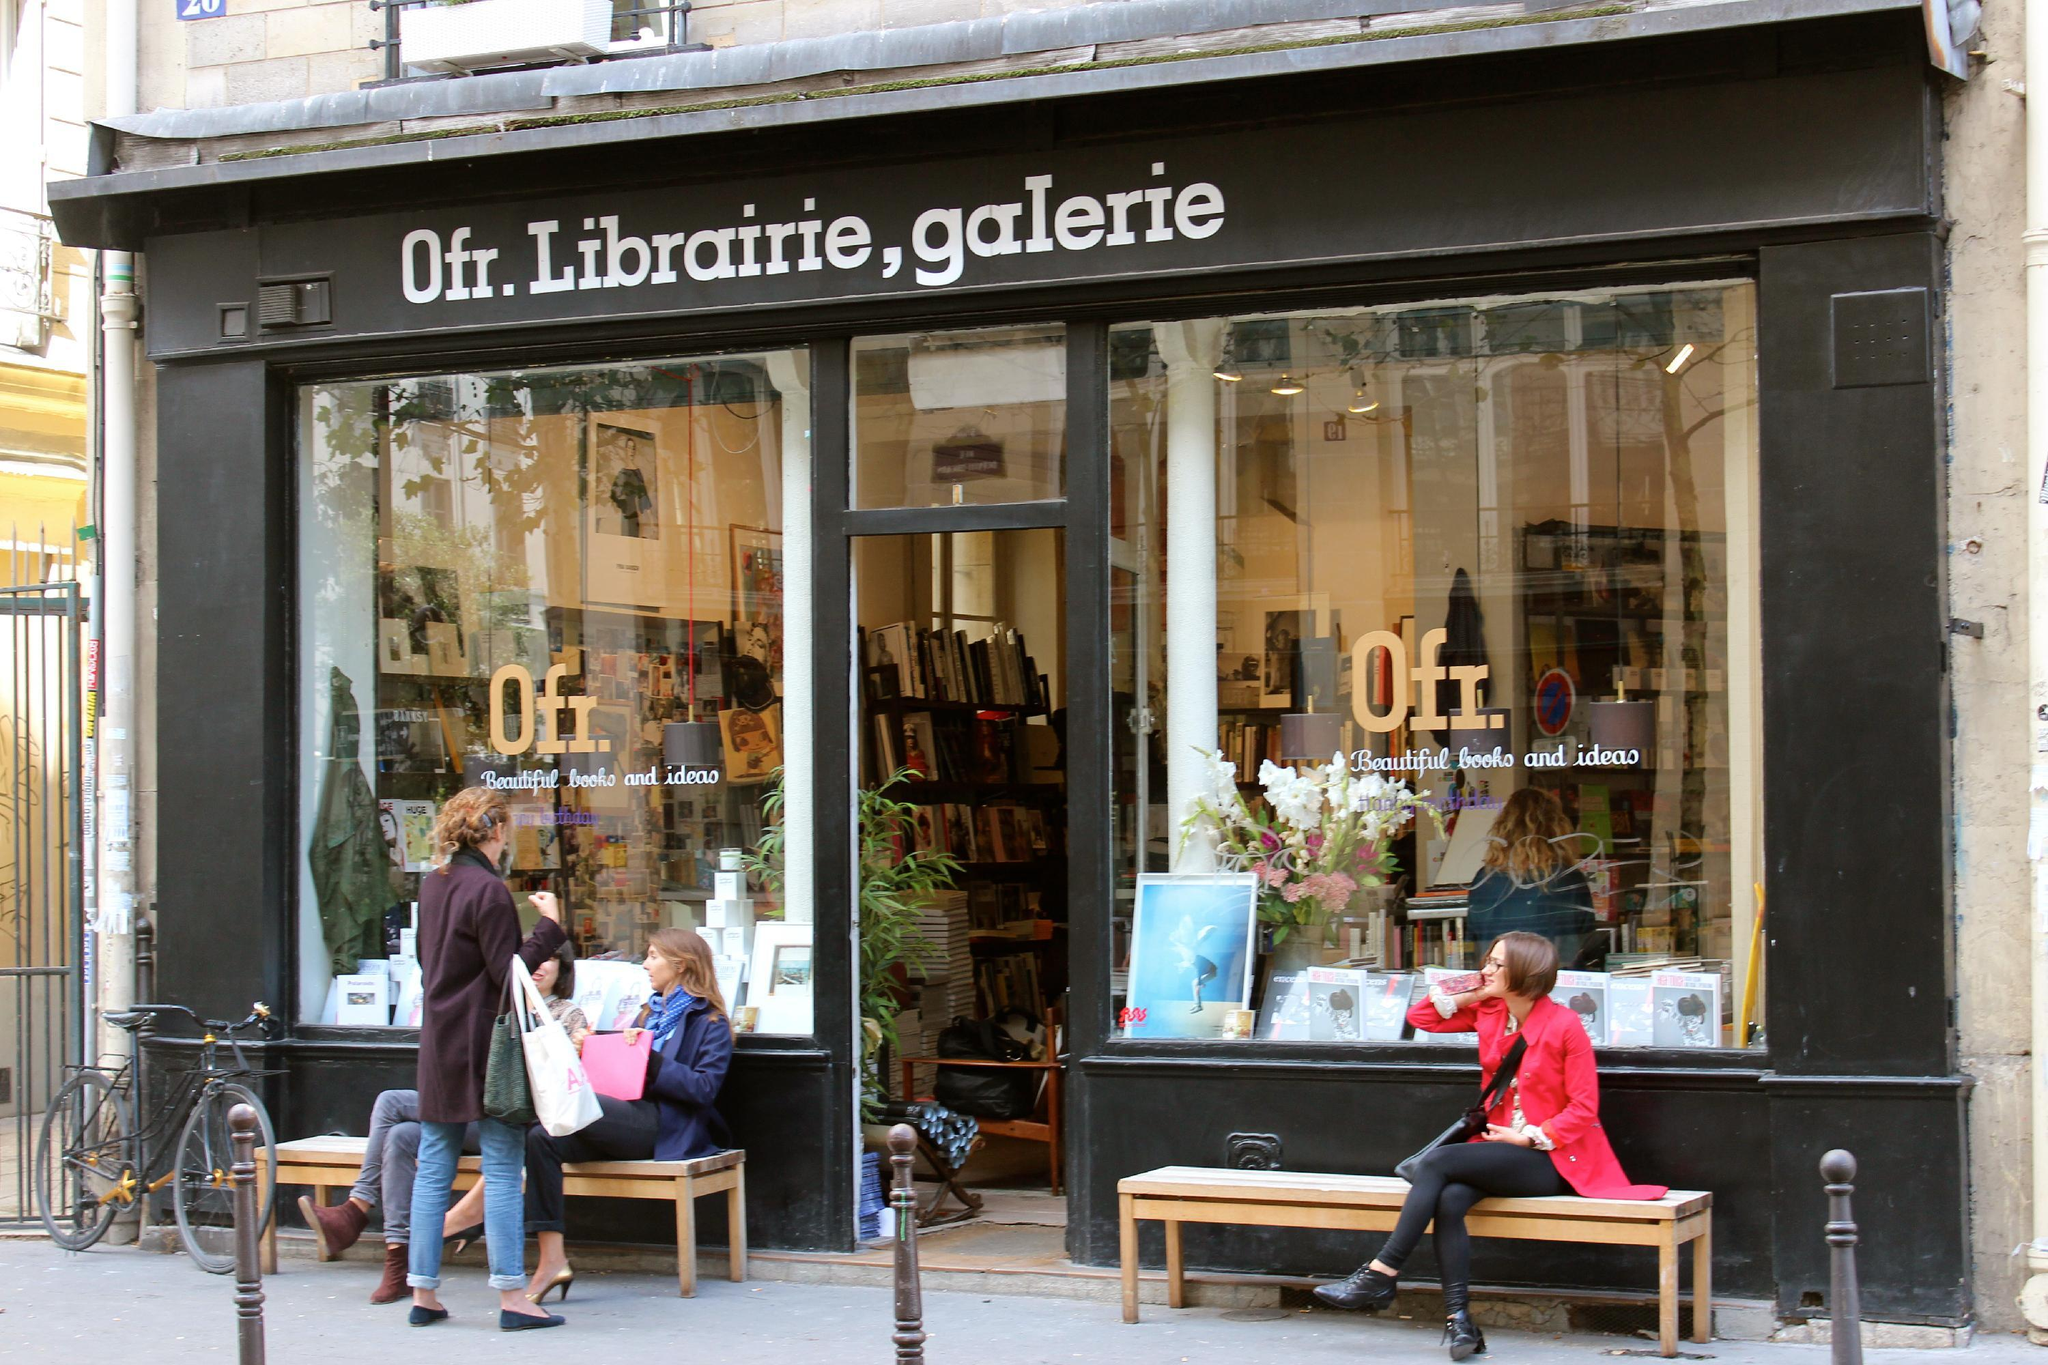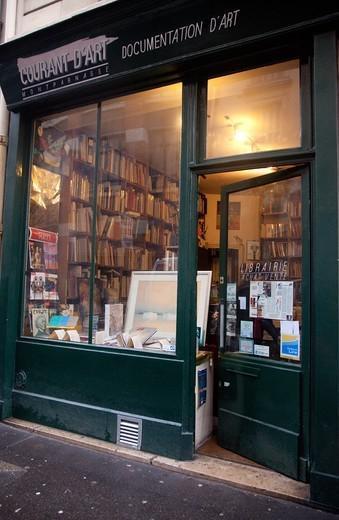The first image is the image on the left, the second image is the image on the right. Examine the images to the left and right. Is the description "There are two bookstore storefronts." accurate? Answer yes or no. Yes. 